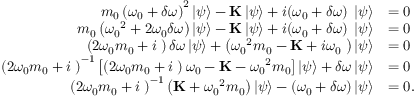<formula> <loc_0><loc_0><loc_500><loc_500>\begin{array} { r l } { { m _ { 0 } \left ( { { \omega _ { 0 } } + \delta \omega } \right ) ^ { 2 } } \left | \psi \right \rangle - \mathbf K \left | \psi \right \rangle + i ( { \omega _ { 0 } } + \delta \omega ) \mathbf \Gamma \left | \psi \right \rangle } & { = 0 } \\ { m _ { 0 } \left ( { { \omega _ { 0 } } ^ { 2 } + 2 { \omega _ { 0 } } \delta \omega } \right ) \left | \psi \right \rangle - \mathbf K \left | \psi \right \rangle + i ( { \omega _ { 0 } } + \delta \omega ) \mathbf \Gamma \left | \psi \right \rangle } & { = 0 } \\ { \left ( { 2 { \omega _ { 0 } } m _ { 0 } + i { \Gamma } } \right ) \delta \omega \left | \psi \right \rangle + \left ( { { \omega _ { 0 } } ^ { 2 } m _ { 0 } - { K } + i { \omega _ { 0 } } { \Gamma } } \right ) \left | \psi \right \rangle } & { = 0 } \\ { { \left ( { 2 { \omega _ { 0 } } m _ { 0 } + i { \Gamma } } \right ) ^ { - 1 } } \left [ { \left ( { 2 { \omega _ { 0 } } { m _ { 0 } } + i { \Gamma } } \right ) { \omega _ { 0 } } - { K } - { \omega _ { 0 } } ^ { 2 } { m _ { 0 } } } \right ] \left | \psi \right \rangle + \delta \omega \left | \psi \right \rangle } & { = 0 } \\ { { \left ( { 2 { \omega _ { 0 } } m _ { 0 } + i { \Gamma } } \right ) ^ { - 1 } } \left ( { { K } + { \omega _ { 0 } } ^ { 2 } m _ { 0 } } \right ) \left | \psi \right \rangle - ( \omega _ { 0 } + \delta \omega ) \left | \psi \right \rangle } & { = 0 . } \end{array}</formula> 